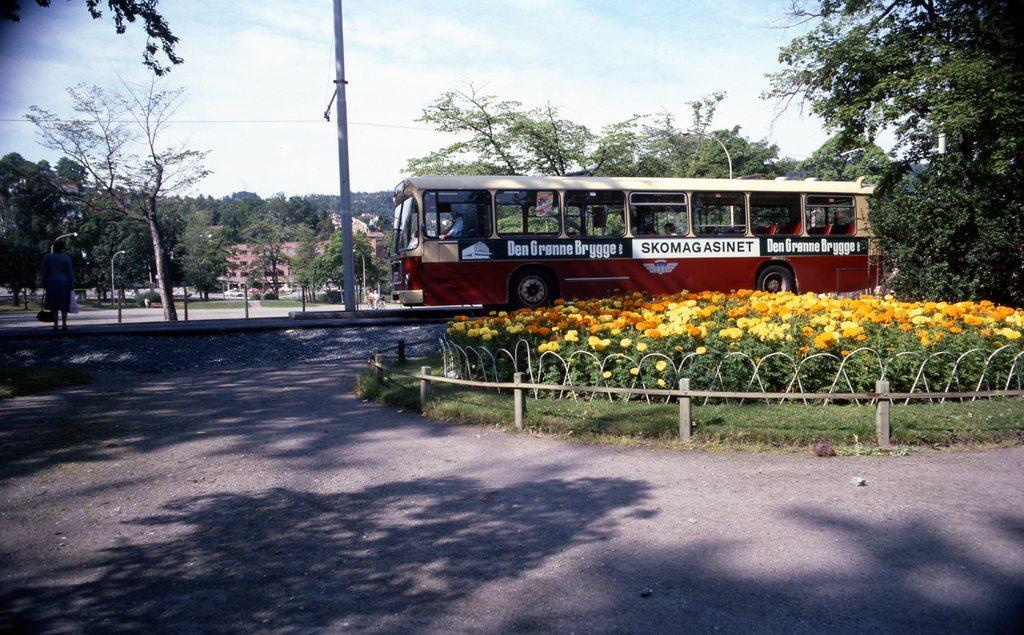Could you give a brief overview of what you see in this image? This picture is clicked outside the city. On the right side of the picture, we see plants in the garden. These plants have flowers which are in yellow and orange color. In the middle of the picture, we see a bus in maroon and white color is moving on the road. Beside that, we see an electric pole. There are trees and buildings in the background. At the top of the picture, we see the sky. At the bottom of the picture, we see the road. 